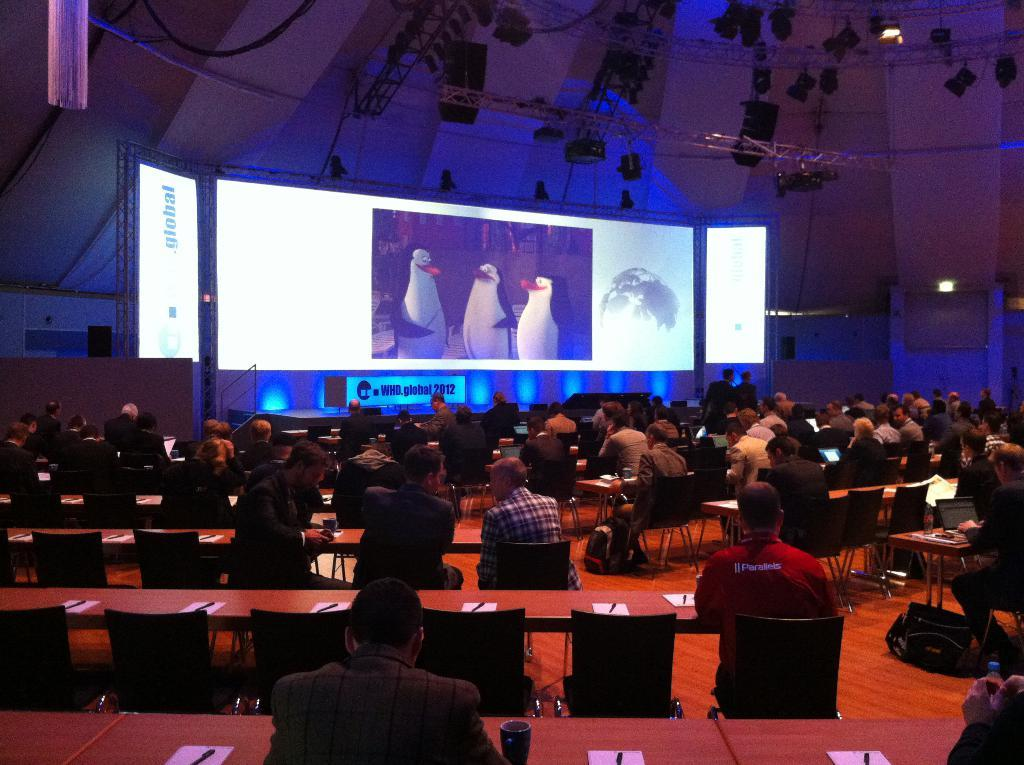What are the people in the image doing? The people in the image are sitting on chairs. What can be seen on the screen in the image? The facts do not provide information about the screen's content. What objects are present on the tables in the image? There are papers on the tables in the image. What type of feast is being prepared on the tables in the image? There is no indication of a feast or any food preparation in the image. 